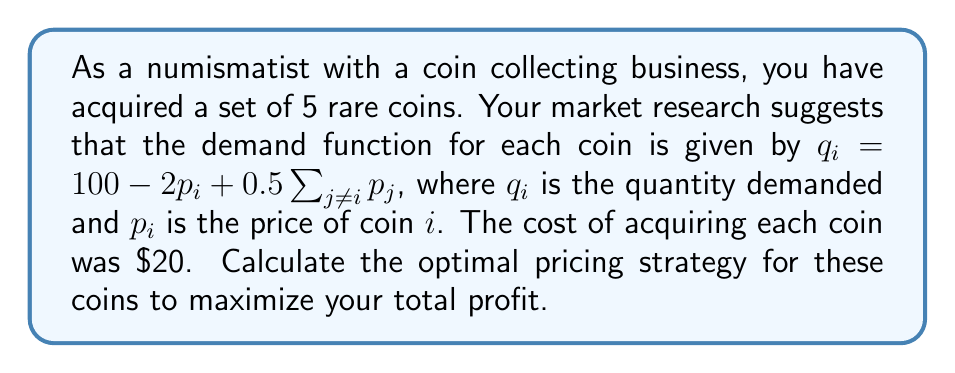Teach me how to tackle this problem. Let's approach this step-by-step:

1) The profit function for each coin is given by:
   $$\pi_i = p_i q_i - 20q_i = (p_i - 20)(100 - 2p_i + 0.5\sum_{j\neq i} p_j)$$

2) The total profit is the sum of profits from all 5 coins:
   $$\Pi = \sum_{i=1}^5 \pi_i$$

3) To maximize profit, we need to find the partial derivatives with respect to each price and set them to zero:
   $$\frac{\partial \Pi}{\partial p_i} = 100 - 4p_i + 0.5\sum_{j\neq i} p_j + (p_i - 20)(-2 + 0.5\sum_{j\neq i} 1) = 0$$

4) Simplifying:
   $$100 - 4p_i + 0.5\sum_{j\neq i} p_j + (p_i - 20)(-2 + 2) = 0$$
   $$100 - 4p_i + 0.5\sum_{j\neq i} p_j = 0$$

5) Due to symmetry, all optimal prices will be equal. Let's call this price $p$. Then:
   $$100 - 4p + 0.5(4p) = 0$$
   $$100 - 2p = 0$$
   $$p = 50$$

6) To verify this is a maximum, we can check the second derivative:
   $$\frac{\partial^2 \Pi}{\partial p_i^2} = -4 < 0$$

7) The optimal quantity for each coin will be:
   $$q = 100 - 2(50) + 0.5(4)(50) = 100$$

8) The total profit will be:
   $$\Pi = 5(50 - 20)(100) = 15000$$

Therefore, the optimal pricing strategy is to price each coin at $\$50$, which will result in a total profit of $\$15,000$.
Answer: Price each coin at $\$50$ for a total profit of $\$15,000$. 